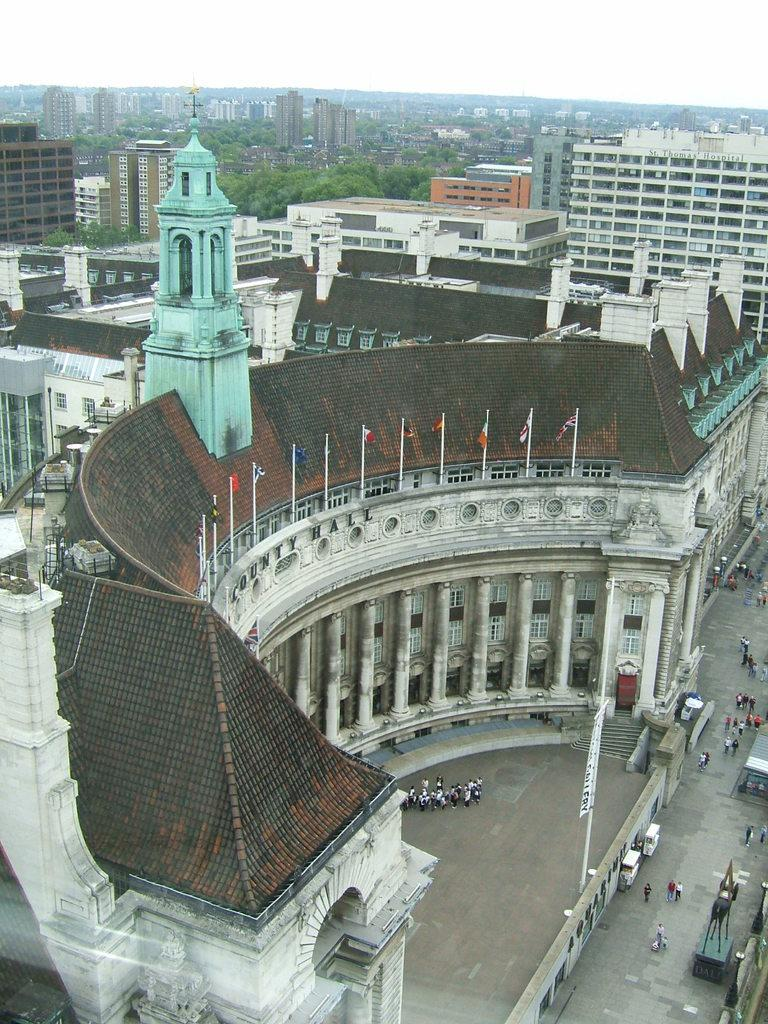What type of view is depicted in the image? The image is an aerial view of a city. What natural elements can be seen in the image? There are trees visible in the image. What man-made structures are present in the image? There are buildings, a tower, flags, pillars, and poles in the image. Are there any people visible in the image? Yes, there are persons visible on the ground in the image. What type of cakes are being sold in the store visible in the image? There is no store visible in the image, and therefore no cakes being sold. What hobbies do the persons in the image engage in? The provided facts do not mention any specific hobbies of the persons visible in the image. 